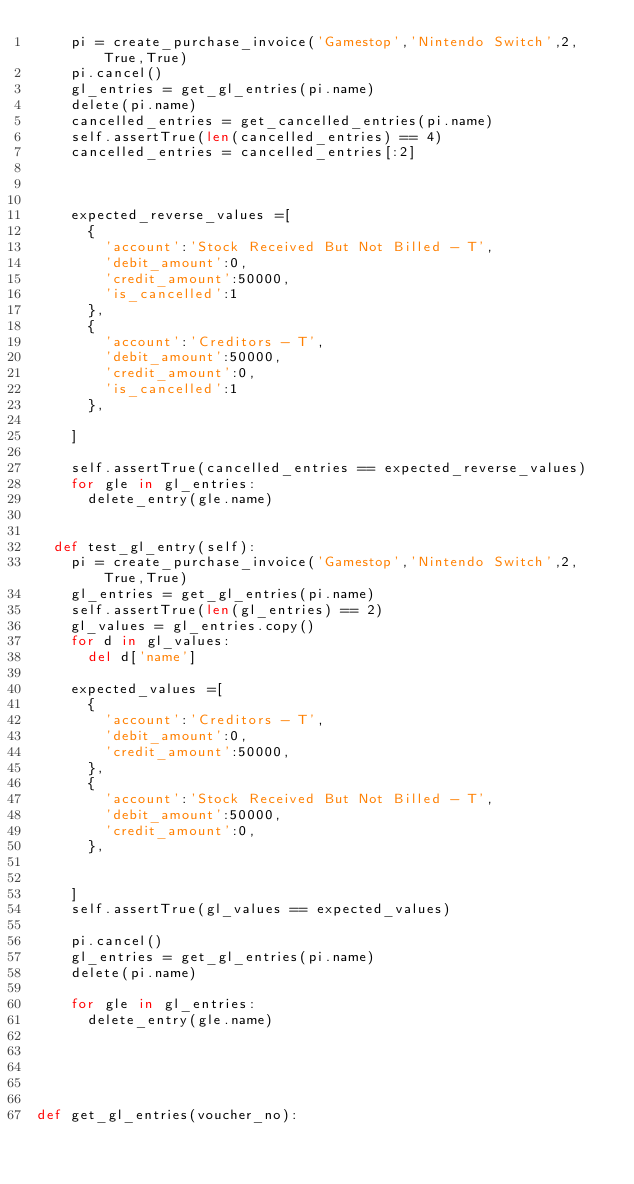Convert code to text. <code><loc_0><loc_0><loc_500><loc_500><_Python_>		pi = create_purchase_invoice('Gamestop','Nintendo Switch',2,True,True)
		pi.cancel()
		gl_entries = get_gl_entries(pi.name)
		delete(pi.name)
		cancelled_entries = get_cancelled_entries(pi.name)
		self.assertTrue(len(cancelled_entries) == 4)
		cancelled_entries = cancelled_entries[:2]
		
		

		expected_reverse_values =[
			{
				'account':'Stock Received But Not Billed - T',
				'debit_amount':0,
				'credit_amount':50000,
				'is_cancelled':1
			},
			{
				'account':'Creditors - T',
				'debit_amount':50000,
				'credit_amount':0,
				'is_cancelled':1
			},

		]

		self.assertTrue(cancelled_entries == expected_reverse_values)
		for gle in gl_entries:
			delete_entry(gle.name)


	def test_gl_entry(self):
		pi = create_purchase_invoice('Gamestop','Nintendo Switch',2,True,True)
		gl_entries = get_gl_entries(pi.name)
		self.assertTrue(len(gl_entries) == 2)
		gl_values = gl_entries.copy()
		for d in gl_values:
			del d['name']

		expected_values =[
			{
				'account':'Creditors - T',
				'debit_amount':0,
				'credit_amount':50000,
			},
			{
				'account':'Stock Received But Not Billed - T',
				'debit_amount':50000,
				'credit_amount':0,
			},
			

		]
		self.assertTrue(gl_values == expected_values)

		pi.cancel()
		gl_entries = get_gl_entries(pi.name)
		delete(pi.name)
		
		for gle in gl_entries:
			delete_entry(gle.name)
		
		



def get_gl_entries(voucher_no):</code> 